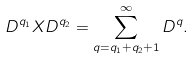Convert formula to latex. <formula><loc_0><loc_0><loc_500><loc_500>D ^ { q _ { 1 } } X D ^ { q _ { 2 } } = \sum _ { q = q _ { 1 } + q _ { 2 } + 1 } ^ { \infty } D ^ { q } .</formula> 